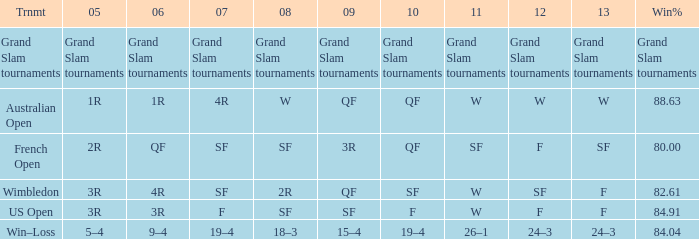Parse the table in full. {'header': ['Trnmt', '05', '06', '07', '08', '09', '10', '11', '12', '13', 'Win%'], 'rows': [['Grand Slam tournaments', 'Grand Slam tournaments', 'Grand Slam tournaments', 'Grand Slam tournaments', 'Grand Slam tournaments', 'Grand Slam tournaments', 'Grand Slam tournaments', 'Grand Slam tournaments', 'Grand Slam tournaments', 'Grand Slam tournaments', 'Grand Slam tournaments'], ['Australian Open', '1R', '1R', '4R', 'W', 'QF', 'QF', 'W', 'W', 'W', '88.63'], ['French Open', '2R', 'QF', 'SF', 'SF', '3R', 'QF', 'SF', 'F', 'SF', '80.00'], ['Wimbledon', '3R', '4R', 'SF', '2R', 'QF', 'SF', 'W', 'SF', 'F', '82.61'], ['US Open', '3R', '3R', 'F', 'SF', 'SF', 'F', 'W', 'F', 'F', '84.91'], ['Win–Loss', '5–4', '9–4', '19–4', '18–3', '15–4', '19–4', '26–1', '24–3', '24–3', '84.04']]} Which Tournament has a 2007 of 19–4? Win–Loss. 